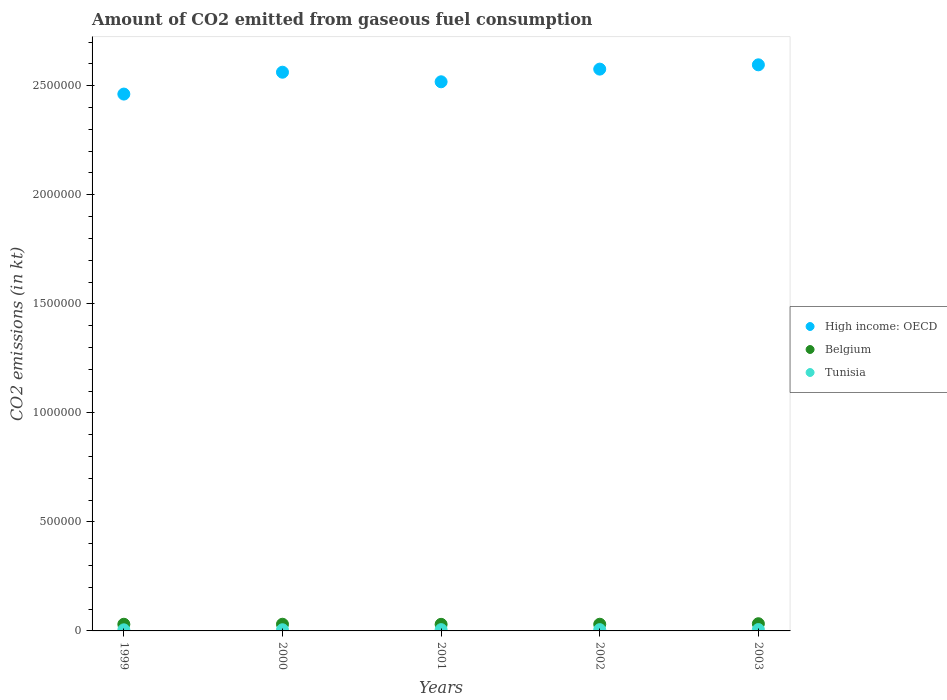What is the amount of CO2 emitted in Belgium in 2002?
Make the answer very short. 3.06e+04. Across all years, what is the maximum amount of CO2 emitted in High income: OECD?
Offer a terse response. 2.60e+06. Across all years, what is the minimum amount of CO2 emitted in Belgium?
Your answer should be compact. 3.02e+04. In which year was the amount of CO2 emitted in Tunisia maximum?
Offer a very short reply. 2003. In which year was the amount of CO2 emitted in Belgium minimum?
Your response must be concise. 2001. What is the total amount of CO2 emitted in Belgium in the graph?
Offer a terse response. 1.55e+05. What is the difference between the amount of CO2 emitted in Belgium in 2000 and that in 2002?
Your answer should be very brief. -22. What is the difference between the amount of CO2 emitted in High income: OECD in 2002 and the amount of CO2 emitted in Belgium in 2001?
Offer a very short reply. 2.55e+06. What is the average amount of CO2 emitted in Tunisia per year?
Provide a short and direct response. 5691.18. In the year 1999, what is the difference between the amount of CO2 emitted in High income: OECD and amount of CO2 emitted in Belgium?
Ensure brevity in your answer.  2.43e+06. What is the ratio of the amount of CO2 emitted in Tunisia in 1999 to that in 2001?
Provide a short and direct response. 0.85. Is the amount of CO2 emitted in High income: OECD in 2000 less than that in 2003?
Keep it short and to the point. Yes. Is the difference between the amount of CO2 emitted in High income: OECD in 2000 and 2003 greater than the difference between the amount of CO2 emitted in Belgium in 2000 and 2003?
Offer a terse response. No. What is the difference between the highest and the second highest amount of CO2 emitted in Tunisia?
Ensure brevity in your answer.  330.03. What is the difference between the highest and the lowest amount of CO2 emitted in Belgium?
Offer a terse response. 2797.92. Is the sum of the amount of CO2 emitted in Belgium in 2002 and 2003 greater than the maximum amount of CO2 emitted in Tunisia across all years?
Provide a succinct answer. Yes. Is it the case that in every year, the sum of the amount of CO2 emitted in Belgium and amount of CO2 emitted in Tunisia  is greater than the amount of CO2 emitted in High income: OECD?
Offer a very short reply. No. Does the amount of CO2 emitted in Belgium monotonically increase over the years?
Provide a short and direct response. No. Is the amount of CO2 emitted in Belgium strictly less than the amount of CO2 emitted in High income: OECD over the years?
Your answer should be very brief. Yes. How many dotlines are there?
Offer a terse response. 3. What is the difference between two consecutive major ticks on the Y-axis?
Ensure brevity in your answer.  5.00e+05. Are the values on the major ticks of Y-axis written in scientific E-notation?
Make the answer very short. No. How many legend labels are there?
Offer a terse response. 3. What is the title of the graph?
Ensure brevity in your answer.  Amount of CO2 emitted from gaseous fuel consumption. Does "Tanzania" appear as one of the legend labels in the graph?
Provide a succinct answer. No. What is the label or title of the X-axis?
Ensure brevity in your answer.  Years. What is the label or title of the Y-axis?
Ensure brevity in your answer.  CO2 emissions (in kt). What is the CO2 emissions (in kt) of High income: OECD in 1999?
Your answer should be compact. 2.46e+06. What is the CO2 emissions (in kt) of Belgium in 1999?
Provide a short and direct response. 3.05e+04. What is the CO2 emissions (in kt) of Tunisia in 1999?
Provide a succinct answer. 5031.12. What is the CO2 emissions (in kt) in High income: OECD in 2000?
Your answer should be compact. 2.56e+06. What is the CO2 emissions (in kt) of Belgium in 2000?
Give a very brief answer. 3.06e+04. What is the CO2 emissions (in kt) of Tunisia in 2000?
Provide a succinct answer. 5339.15. What is the CO2 emissions (in kt) in High income: OECD in 2001?
Your response must be concise. 2.52e+06. What is the CO2 emissions (in kt) in Belgium in 2001?
Provide a succinct answer. 3.02e+04. What is the CO2 emissions (in kt) of Tunisia in 2001?
Provide a short and direct response. 5918.54. What is the CO2 emissions (in kt) of High income: OECD in 2002?
Your response must be concise. 2.58e+06. What is the CO2 emissions (in kt) of Belgium in 2002?
Your response must be concise. 3.06e+04. What is the CO2 emissions (in kt) of Tunisia in 2002?
Offer a terse response. 5918.54. What is the CO2 emissions (in kt) of High income: OECD in 2003?
Ensure brevity in your answer.  2.60e+06. What is the CO2 emissions (in kt) in Belgium in 2003?
Provide a succinct answer. 3.30e+04. What is the CO2 emissions (in kt) in Tunisia in 2003?
Your answer should be compact. 6248.57. Across all years, what is the maximum CO2 emissions (in kt) of High income: OECD?
Your response must be concise. 2.60e+06. Across all years, what is the maximum CO2 emissions (in kt) of Belgium?
Keep it short and to the point. 3.30e+04. Across all years, what is the maximum CO2 emissions (in kt) in Tunisia?
Ensure brevity in your answer.  6248.57. Across all years, what is the minimum CO2 emissions (in kt) of High income: OECD?
Your response must be concise. 2.46e+06. Across all years, what is the minimum CO2 emissions (in kt) of Belgium?
Give a very brief answer. 3.02e+04. Across all years, what is the minimum CO2 emissions (in kt) in Tunisia?
Offer a very short reply. 5031.12. What is the total CO2 emissions (in kt) in High income: OECD in the graph?
Offer a very short reply. 1.27e+07. What is the total CO2 emissions (in kt) of Belgium in the graph?
Your response must be concise. 1.55e+05. What is the total CO2 emissions (in kt) of Tunisia in the graph?
Your answer should be very brief. 2.85e+04. What is the difference between the CO2 emissions (in kt) of High income: OECD in 1999 and that in 2000?
Provide a short and direct response. -1.00e+05. What is the difference between the CO2 emissions (in kt) in Belgium in 1999 and that in 2000?
Give a very brief answer. -77.01. What is the difference between the CO2 emissions (in kt) in Tunisia in 1999 and that in 2000?
Your answer should be compact. -308.03. What is the difference between the CO2 emissions (in kt) in High income: OECD in 1999 and that in 2001?
Provide a short and direct response. -5.63e+04. What is the difference between the CO2 emissions (in kt) of Belgium in 1999 and that in 2001?
Ensure brevity in your answer.  355.7. What is the difference between the CO2 emissions (in kt) of Tunisia in 1999 and that in 2001?
Offer a very short reply. -887.41. What is the difference between the CO2 emissions (in kt) of High income: OECD in 1999 and that in 2002?
Offer a very short reply. -1.14e+05. What is the difference between the CO2 emissions (in kt) in Belgium in 1999 and that in 2002?
Your answer should be very brief. -99.01. What is the difference between the CO2 emissions (in kt) of Tunisia in 1999 and that in 2002?
Your answer should be very brief. -887.41. What is the difference between the CO2 emissions (in kt) in High income: OECD in 1999 and that in 2003?
Keep it short and to the point. -1.34e+05. What is the difference between the CO2 emissions (in kt) of Belgium in 1999 and that in 2003?
Provide a succinct answer. -2442.22. What is the difference between the CO2 emissions (in kt) in Tunisia in 1999 and that in 2003?
Provide a succinct answer. -1217.44. What is the difference between the CO2 emissions (in kt) in High income: OECD in 2000 and that in 2001?
Your answer should be very brief. 4.39e+04. What is the difference between the CO2 emissions (in kt) of Belgium in 2000 and that in 2001?
Your response must be concise. 432.71. What is the difference between the CO2 emissions (in kt) of Tunisia in 2000 and that in 2001?
Your answer should be compact. -579.39. What is the difference between the CO2 emissions (in kt) of High income: OECD in 2000 and that in 2002?
Your response must be concise. -1.42e+04. What is the difference between the CO2 emissions (in kt) of Belgium in 2000 and that in 2002?
Make the answer very short. -22. What is the difference between the CO2 emissions (in kt) of Tunisia in 2000 and that in 2002?
Your answer should be very brief. -579.39. What is the difference between the CO2 emissions (in kt) in High income: OECD in 2000 and that in 2003?
Keep it short and to the point. -3.39e+04. What is the difference between the CO2 emissions (in kt) of Belgium in 2000 and that in 2003?
Provide a succinct answer. -2365.22. What is the difference between the CO2 emissions (in kt) in Tunisia in 2000 and that in 2003?
Give a very brief answer. -909.42. What is the difference between the CO2 emissions (in kt) of High income: OECD in 2001 and that in 2002?
Offer a terse response. -5.81e+04. What is the difference between the CO2 emissions (in kt) of Belgium in 2001 and that in 2002?
Provide a short and direct response. -454.71. What is the difference between the CO2 emissions (in kt) of High income: OECD in 2001 and that in 2003?
Your answer should be very brief. -7.78e+04. What is the difference between the CO2 emissions (in kt) of Belgium in 2001 and that in 2003?
Make the answer very short. -2797.92. What is the difference between the CO2 emissions (in kt) of Tunisia in 2001 and that in 2003?
Ensure brevity in your answer.  -330.03. What is the difference between the CO2 emissions (in kt) of High income: OECD in 2002 and that in 2003?
Ensure brevity in your answer.  -1.97e+04. What is the difference between the CO2 emissions (in kt) of Belgium in 2002 and that in 2003?
Keep it short and to the point. -2343.21. What is the difference between the CO2 emissions (in kt) in Tunisia in 2002 and that in 2003?
Make the answer very short. -330.03. What is the difference between the CO2 emissions (in kt) of High income: OECD in 1999 and the CO2 emissions (in kt) of Belgium in 2000?
Ensure brevity in your answer.  2.43e+06. What is the difference between the CO2 emissions (in kt) of High income: OECD in 1999 and the CO2 emissions (in kt) of Tunisia in 2000?
Your answer should be compact. 2.46e+06. What is the difference between the CO2 emissions (in kt) in Belgium in 1999 and the CO2 emissions (in kt) in Tunisia in 2000?
Your response must be concise. 2.52e+04. What is the difference between the CO2 emissions (in kt) of High income: OECD in 1999 and the CO2 emissions (in kt) of Belgium in 2001?
Your answer should be compact. 2.43e+06. What is the difference between the CO2 emissions (in kt) of High income: OECD in 1999 and the CO2 emissions (in kt) of Tunisia in 2001?
Your answer should be very brief. 2.46e+06. What is the difference between the CO2 emissions (in kt) in Belgium in 1999 and the CO2 emissions (in kt) in Tunisia in 2001?
Offer a terse response. 2.46e+04. What is the difference between the CO2 emissions (in kt) in High income: OECD in 1999 and the CO2 emissions (in kt) in Belgium in 2002?
Provide a succinct answer. 2.43e+06. What is the difference between the CO2 emissions (in kt) in High income: OECD in 1999 and the CO2 emissions (in kt) in Tunisia in 2002?
Offer a very short reply. 2.46e+06. What is the difference between the CO2 emissions (in kt) of Belgium in 1999 and the CO2 emissions (in kt) of Tunisia in 2002?
Your answer should be very brief. 2.46e+04. What is the difference between the CO2 emissions (in kt) in High income: OECD in 1999 and the CO2 emissions (in kt) in Belgium in 2003?
Offer a terse response. 2.43e+06. What is the difference between the CO2 emissions (in kt) of High income: OECD in 1999 and the CO2 emissions (in kt) of Tunisia in 2003?
Keep it short and to the point. 2.46e+06. What is the difference between the CO2 emissions (in kt) of Belgium in 1999 and the CO2 emissions (in kt) of Tunisia in 2003?
Give a very brief answer. 2.43e+04. What is the difference between the CO2 emissions (in kt) in High income: OECD in 2000 and the CO2 emissions (in kt) in Belgium in 2001?
Offer a terse response. 2.53e+06. What is the difference between the CO2 emissions (in kt) of High income: OECD in 2000 and the CO2 emissions (in kt) of Tunisia in 2001?
Provide a succinct answer. 2.56e+06. What is the difference between the CO2 emissions (in kt) of Belgium in 2000 and the CO2 emissions (in kt) of Tunisia in 2001?
Give a very brief answer. 2.47e+04. What is the difference between the CO2 emissions (in kt) of High income: OECD in 2000 and the CO2 emissions (in kt) of Belgium in 2002?
Provide a succinct answer. 2.53e+06. What is the difference between the CO2 emissions (in kt) of High income: OECD in 2000 and the CO2 emissions (in kt) of Tunisia in 2002?
Ensure brevity in your answer.  2.56e+06. What is the difference between the CO2 emissions (in kt) in Belgium in 2000 and the CO2 emissions (in kt) in Tunisia in 2002?
Your answer should be compact. 2.47e+04. What is the difference between the CO2 emissions (in kt) of High income: OECD in 2000 and the CO2 emissions (in kt) of Belgium in 2003?
Ensure brevity in your answer.  2.53e+06. What is the difference between the CO2 emissions (in kt) in High income: OECD in 2000 and the CO2 emissions (in kt) in Tunisia in 2003?
Offer a very short reply. 2.56e+06. What is the difference between the CO2 emissions (in kt) of Belgium in 2000 and the CO2 emissions (in kt) of Tunisia in 2003?
Make the answer very short. 2.44e+04. What is the difference between the CO2 emissions (in kt) of High income: OECD in 2001 and the CO2 emissions (in kt) of Belgium in 2002?
Make the answer very short. 2.49e+06. What is the difference between the CO2 emissions (in kt) in High income: OECD in 2001 and the CO2 emissions (in kt) in Tunisia in 2002?
Make the answer very short. 2.51e+06. What is the difference between the CO2 emissions (in kt) in Belgium in 2001 and the CO2 emissions (in kt) in Tunisia in 2002?
Offer a terse response. 2.43e+04. What is the difference between the CO2 emissions (in kt) in High income: OECD in 2001 and the CO2 emissions (in kt) in Belgium in 2003?
Your answer should be very brief. 2.49e+06. What is the difference between the CO2 emissions (in kt) of High income: OECD in 2001 and the CO2 emissions (in kt) of Tunisia in 2003?
Your response must be concise. 2.51e+06. What is the difference between the CO2 emissions (in kt) of Belgium in 2001 and the CO2 emissions (in kt) of Tunisia in 2003?
Your response must be concise. 2.39e+04. What is the difference between the CO2 emissions (in kt) in High income: OECD in 2002 and the CO2 emissions (in kt) in Belgium in 2003?
Your answer should be compact. 2.54e+06. What is the difference between the CO2 emissions (in kt) in High income: OECD in 2002 and the CO2 emissions (in kt) in Tunisia in 2003?
Your response must be concise. 2.57e+06. What is the difference between the CO2 emissions (in kt) of Belgium in 2002 and the CO2 emissions (in kt) of Tunisia in 2003?
Your answer should be very brief. 2.44e+04. What is the average CO2 emissions (in kt) in High income: OECD per year?
Keep it short and to the point. 2.54e+06. What is the average CO2 emissions (in kt) of Belgium per year?
Offer a very short reply. 3.10e+04. What is the average CO2 emissions (in kt) of Tunisia per year?
Offer a terse response. 5691.18. In the year 1999, what is the difference between the CO2 emissions (in kt) in High income: OECD and CO2 emissions (in kt) in Belgium?
Ensure brevity in your answer.  2.43e+06. In the year 1999, what is the difference between the CO2 emissions (in kt) of High income: OECD and CO2 emissions (in kt) of Tunisia?
Offer a terse response. 2.46e+06. In the year 1999, what is the difference between the CO2 emissions (in kt) in Belgium and CO2 emissions (in kt) in Tunisia?
Provide a short and direct response. 2.55e+04. In the year 2000, what is the difference between the CO2 emissions (in kt) of High income: OECD and CO2 emissions (in kt) of Belgium?
Offer a very short reply. 2.53e+06. In the year 2000, what is the difference between the CO2 emissions (in kt) in High income: OECD and CO2 emissions (in kt) in Tunisia?
Give a very brief answer. 2.56e+06. In the year 2000, what is the difference between the CO2 emissions (in kt) in Belgium and CO2 emissions (in kt) in Tunisia?
Keep it short and to the point. 2.53e+04. In the year 2001, what is the difference between the CO2 emissions (in kt) in High income: OECD and CO2 emissions (in kt) in Belgium?
Give a very brief answer. 2.49e+06. In the year 2001, what is the difference between the CO2 emissions (in kt) of High income: OECD and CO2 emissions (in kt) of Tunisia?
Offer a terse response. 2.51e+06. In the year 2001, what is the difference between the CO2 emissions (in kt) in Belgium and CO2 emissions (in kt) in Tunisia?
Offer a terse response. 2.43e+04. In the year 2002, what is the difference between the CO2 emissions (in kt) in High income: OECD and CO2 emissions (in kt) in Belgium?
Keep it short and to the point. 2.55e+06. In the year 2002, what is the difference between the CO2 emissions (in kt) of High income: OECD and CO2 emissions (in kt) of Tunisia?
Provide a short and direct response. 2.57e+06. In the year 2002, what is the difference between the CO2 emissions (in kt) of Belgium and CO2 emissions (in kt) of Tunisia?
Ensure brevity in your answer.  2.47e+04. In the year 2003, what is the difference between the CO2 emissions (in kt) of High income: OECD and CO2 emissions (in kt) of Belgium?
Your answer should be very brief. 2.56e+06. In the year 2003, what is the difference between the CO2 emissions (in kt) of High income: OECD and CO2 emissions (in kt) of Tunisia?
Offer a very short reply. 2.59e+06. In the year 2003, what is the difference between the CO2 emissions (in kt) of Belgium and CO2 emissions (in kt) of Tunisia?
Your answer should be very brief. 2.67e+04. What is the ratio of the CO2 emissions (in kt) in High income: OECD in 1999 to that in 2000?
Your response must be concise. 0.96. What is the ratio of the CO2 emissions (in kt) of Belgium in 1999 to that in 2000?
Ensure brevity in your answer.  1. What is the ratio of the CO2 emissions (in kt) in Tunisia in 1999 to that in 2000?
Your response must be concise. 0.94. What is the ratio of the CO2 emissions (in kt) in High income: OECD in 1999 to that in 2001?
Offer a very short reply. 0.98. What is the ratio of the CO2 emissions (in kt) in Belgium in 1999 to that in 2001?
Provide a succinct answer. 1.01. What is the ratio of the CO2 emissions (in kt) in Tunisia in 1999 to that in 2001?
Your answer should be compact. 0.85. What is the ratio of the CO2 emissions (in kt) of High income: OECD in 1999 to that in 2002?
Provide a succinct answer. 0.96. What is the ratio of the CO2 emissions (in kt) in Belgium in 1999 to that in 2002?
Your response must be concise. 1. What is the ratio of the CO2 emissions (in kt) of Tunisia in 1999 to that in 2002?
Give a very brief answer. 0.85. What is the ratio of the CO2 emissions (in kt) in High income: OECD in 1999 to that in 2003?
Give a very brief answer. 0.95. What is the ratio of the CO2 emissions (in kt) in Belgium in 1999 to that in 2003?
Keep it short and to the point. 0.93. What is the ratio of the CO2 emissions (in kt) in Tunisia in 1999 to that in 2003?
Provide a short and direct response. 0.81. What is the ratio of the CO2 emissions (in kt) in High income: OECD in 2000 to that in 2001?
Your response must be concise. 1.02. What is the ratio of the CO2 emissions (in kt) in Belgium in 2000 to that in 2001?
Make the answer very short. 1.01. What is the ratio of the CO2 emissions (in kt) of Tunisia in 2000 to that in 2001?
Ensure brevity in your answer.  0.9. What is the ratio of the CO2 emissions (in kt) in High income: OECD in 2000 to that in 2002?
Give a very brief answer. 0.99. What is the ratio of the CO2 emissions (in kt) of Belgium in 2000 to that in 2002?
Make the answer very short. 1. What is the ratio of the CO2 emissions (in kt) in Tunisia in 2000 to that in 2002?
Offer a terse response. 0.9. What is the ratio of the CO2 emissions (in kt) of High income: OECD in 2000 to that in 2003?
Your response must be concise. 0.99. What is the ratio of the CO2 emissions (in kt) of Belgium in 2000 to that in 2003?
Keep it short and to the point. 0.93. What is the ratio of the CO2 emissions (in kt) of Tunisia in 2000 to that in 2003?
Your answer should be compact. 0.85. What is the ratio of the CO2 emissions (in kt) in High income: OECD in 2001 to that in 2002?
Keep it short and to the point. 0.98. What is the ratio of the CO2 emissions (in kt) of Belgium in 2001 to that in 2002?
Ensure brevity in your answer.  0.99. What is the ratio of the CO2 emissions (in kt) of Tunisia in 2001 to that in 2002?
Give a very brief answer. 1. What is the ratio of the CO2 emissions (in kt) in High income: OECD in 2001 to that in 2003?
Your response must be concise. 0.97. What is the ratio of the CO2 emissions (in kt) in Belgium in 2001 to that in 2003?
Make the answer very short. 0.92. What is the ratio of the CO2 emissions (in kt) of Tunisia in 2001 to that in 2003?
Your answer should be compact. 0.95. What is the ratio of the CO2 emissions (in kt) of Belgium in 2002 to that in 2003?
Keep it short and to the point. 0.93. What is the ratio of the CO2 emissions (in kt) of Tunisia in 2002 to that in 2003?
Provide a short and direct response. 0.95. What is the difference between the highest and the second highest CO2 emissions (in kt) of High income: OECD?
Provide a short and direct response. 1.97e+04. What is the difference between the highest and the second highest CO2 emissions (in kt) of Belgium?
Your answer should be compact. 2343.21. What is the difference between the highest and the second highest CO2 emissions (in kt) in Tunisia?
Offer a very short reply. 330.03. What is the difference between the highest and the lowest CO2 emissions (in kt) of High income: OECD?
Keep it short and to the point. 1.34e+05. What is the difference between the highest and the lowest CO2 emissions (in kt) of Belgium?
Your response must be concise. 2797.92. What is the difference between the highest and the lowest CO2 emissions (in kt) of Tunisia?
Offer a very short reply. 1217.44. 